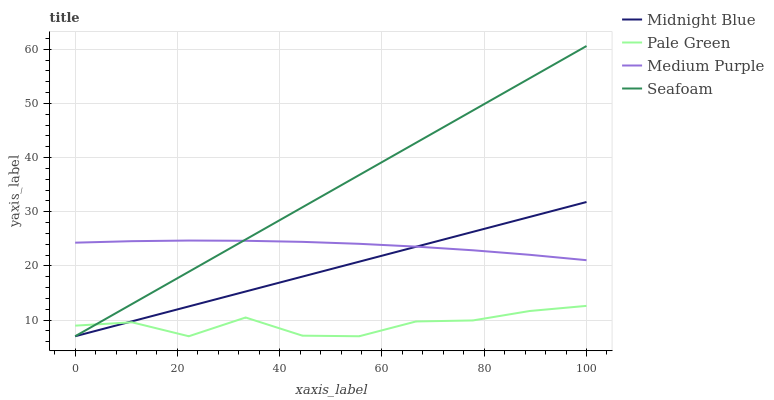Does Midnight Blue have the minimum area under the curve?
Answer yes or no. No. Does Midnight Blue have the maximum area under the curve?
Answer yes or no. No. Is Pale Green the smoothest?
Answer yes or no. No. Is Midnight Blue the roughest?
Answer yes or no. No. Does Midnight Blue have the highest value?
Answer yes or no. No. Is Pale Green less than Medium Purple?
Answer yes or no. Yes. Is Medium Purple greater than Pale Green?
Answer yes or no. Yes. Does Pale Green intersect Medium Purple?
Answer yes or no. No. 